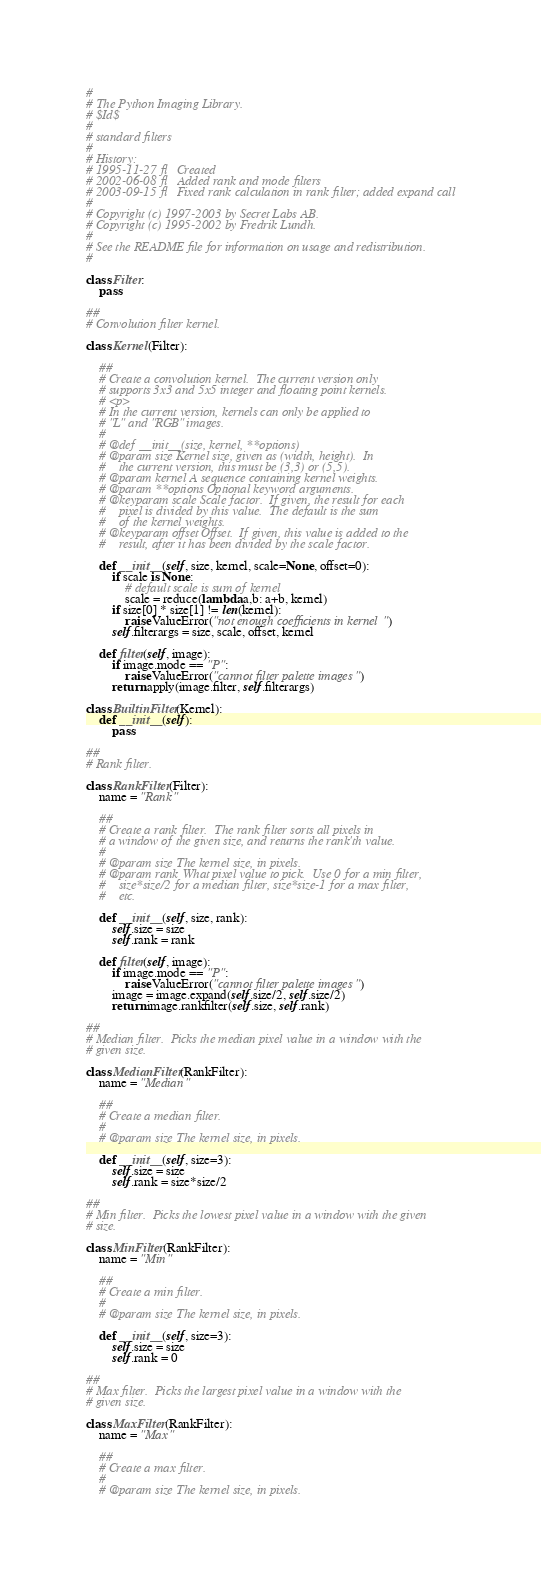Convert code to text. <code><loc_0><loc_0><loc_500><loc_500><_Python_>#
# The Python Imaging Library.
# $Id$
#
# standard filters
#
# History:
# 1995-11-27 fl   Created
# 2002-06-08 fl   Added rank and mode filters
# 2003-09-15 fl   Fixed rank calculation in rank filter; added expand call
#
# Copyright (c) 1997-2003 by Secret Labs AB.
# Copyright (c) 1995-2002 by Fredrik Lundh.
#
# See the README file for information on usage and redistribution.
#

class Filter:
    pass

##
# Convolution filter kernel.

class Kernel(Filter):

    ##
    # Create a convolution kernel.  The current version only
    # supports 3x3 and 5x5 integer and floating point kernels.
    # <p>
    # In the current version, kernels can only be applied to
    # "L" and "RGB" images.
    #
    # @def __init__(size, kernel, **options)
    # @param size Kernel size, given as (width, height).  In
    #    the current version, this must be (3,3) or (5,5).
    # @param kernel A sequence containing kernel weights.
    # @param **options Optional keyword arguments.
    # @keyparam scale Scale factor.  If given, the result for each
    #    pixel is divided by this value.  The default is the sum
    #    of the kernel weights.
    # @keyparam offset Offset.  If given, this value is added to the
    #    result, after it has been divided by the scale factor.

    def __init__(self, size, kernel, scale=None, offset=0):
        if scale is None:
            # default scale is sum of kernel
            scale = reduce(lambda a,b: a+b, kernel)
        if size[0] * size[1] != len(kernel):
            raise ValueError("not enough coefficients in kernel")
        self.filterargs = size, scale, offset, kernel

    def filter(self, image):
        if image.mode == "P":
            raise ValueError("cannot filter palette images")
        return apply(image.filter, self.filterargs)

class BuiltinFilter(Kernel):
    def __init__(self):
        pass

##
# Rank filter.

class RankFilter(Filter):
    name = "Rank"

    ##
    # Create a rank filter.  The rank filter sorts all pixels in
    # a window of the given size, and returns the rank'th value.
    #
    # @param size The kernel size, in pixels.
    # @param rank What pixel value to pick.  Use 0 for a min filter,
    #    size*size/2 for a median filter, size*size-1 for a max filter,
    #    etc.

    def __init__(self, size, rank):
        self.size = size
        self.rank = rank

    def filter(self, image):
        if image.mode == "P":
            raise ValueError("cannot filter palette images")
        image = image.expand(self.size/2, self.size/2)
        return image.rankfilter(self.size, self.rank)

##
# Median filter.  Picks the median pixel value in a window with the
# given size.

class MedianFilter(RankFilter):
    name = "Median"

    ##
    # Create a median filter.
    #
    # @param size The kernel size, in pixels.

    def __init__(self, size=3):
        self.size = size
        self.rank = size*size/2

##
# Min filter.  Picks the lowest pixel value in a window with the given
# size.

class MinFilter(RankFilter):
    name = "Min"

    ##
    # Create a min filter.
    #
    # @param size The kernel size, in pixels.

    def __init__(self, size=3):
        self.size = size
        self.rank = 0

##
# Max filter.  Picks the largest pixel value in a window with the
# given size.

class MaxFilter(RankFilter):
    name = "Max"

    ##
    # Create a max filter.
    #
    # @param size The kernel size, in pixels.
</code> 